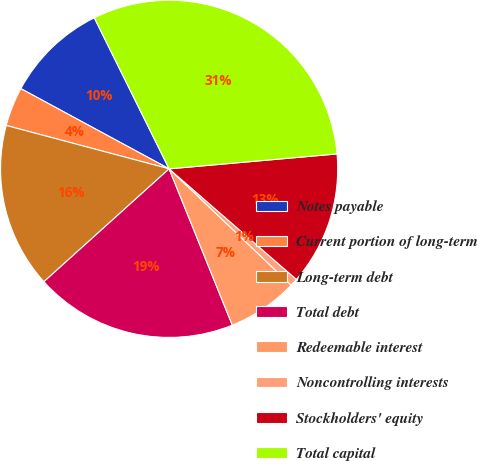<chart> <loc_0><loc_0><loc_500><loc_500><pie_chart><fcel>Notes payable<fcel>Current portion of long-term<fcel>Long-term debt<fcel>Total debt<fcel>Redeemable interest<fcel>Noncontrolling interests<fcel>Stockholders' equity<fcel>Total capital<nl><fcel>9.79%<fcel>3.75%<fcel>15.82%<fcel>19.44%<fcel>6.77%<fcel>0.73%<fcel>12.8%<fcel>30.91%<nl></chart> 